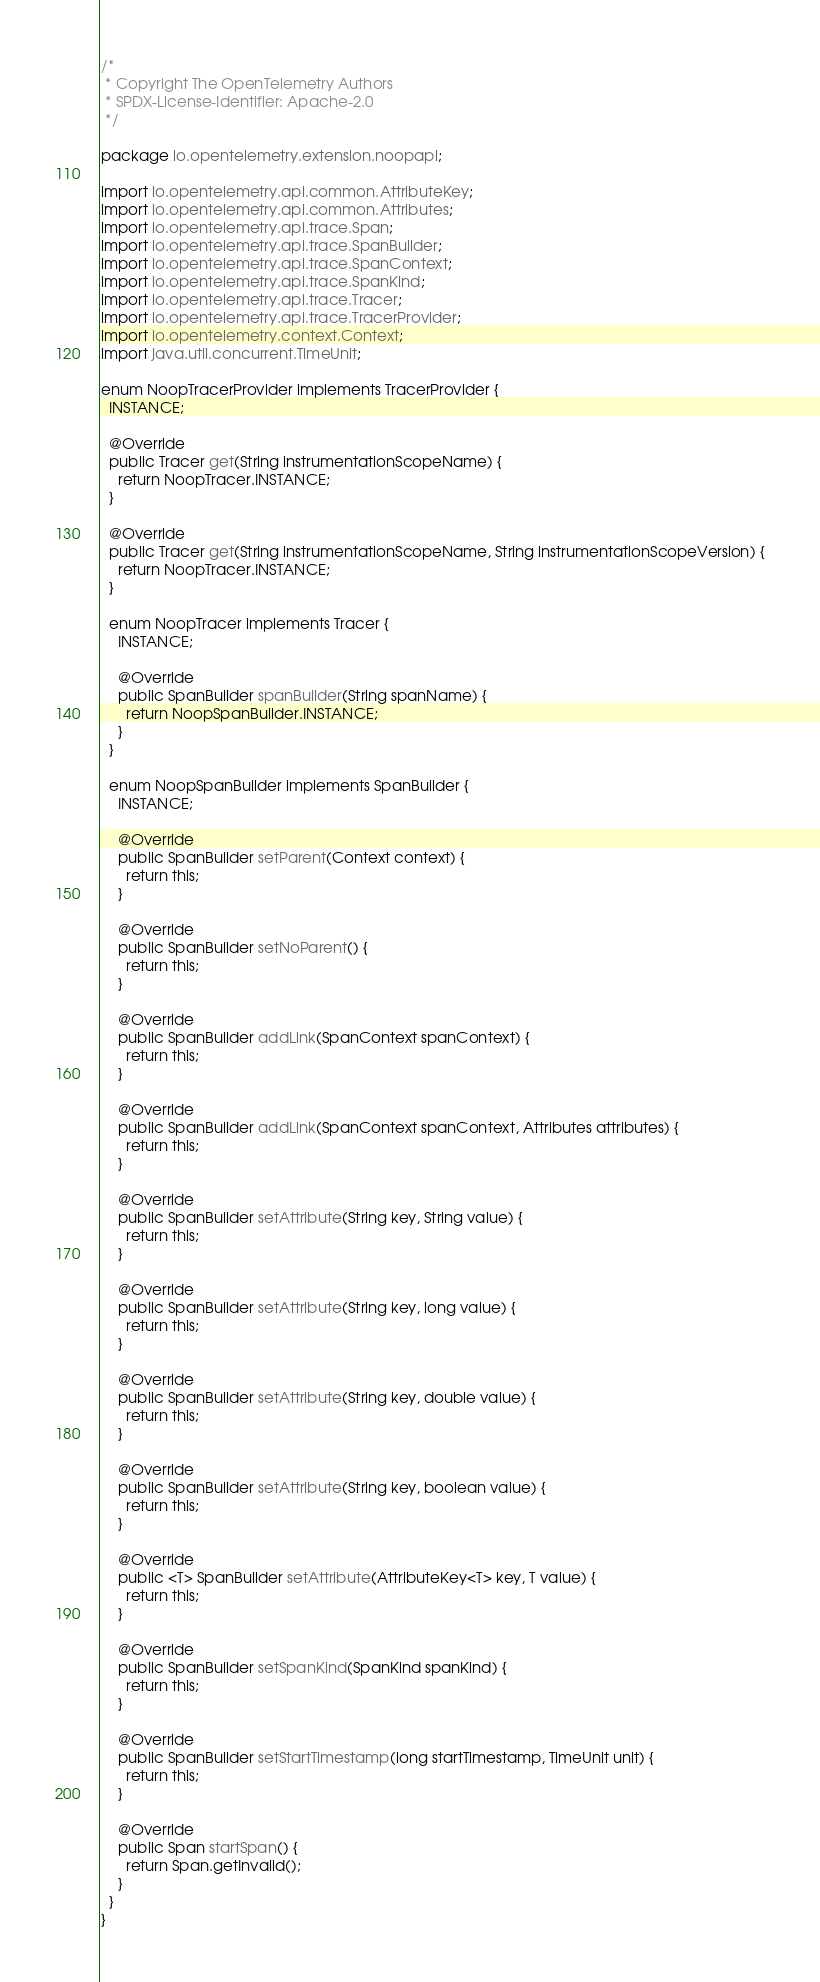Convert code to text. <code><loc_0><loc_0><loc_500><loc_500><_Java_>/*
 * Copyright The OpenTelemetry Authors
 * SPDX-License-Identifier: Apache-2.0
 */

package io.opentelemetry.extension.noopapi;

import io.opentelemetry.api.common.AttributeKey;
import io.opentelemetry.api.common.Attributes;
import io.opentelemetry.api.trace.Span;
import io.opentelemetry.api.trace.SpanBuilder;
import io.opentelemetry.api.trace.SpanContext;
import io.opentelemetry.api.trace.SpanKind;
import io.opentelemetry.api.trace.Tracer;
import io.opentelemetry.api.trace.TracerProvider;
import io.opentelemetry.context.Context;
import java.util.concurrent.TimeUnit;

enum NoopTracerProvider implements TracerProvider {
  INSTANCE;

  @Override
  public Tracer get(String instrumentationScopeName) {
    return NoopTracer.INSTANCE;
  }

  @Override
  public Tracer get(String instrumentationScopeName, String instrumentationScopeVersion) {
    return NoopTracer.INSTANCE;
  }

  enum NoopTracer implements Tracer {
    INSTANCE;

    @Override
    public SpanBuilder spanBuilder(String spanName) {
      return NoopSpanBuilder.INSTANCE;
    }
  }

  enum NoopSpanBuilder implements SpanBuilder {
    INSTANCE;

    @Override
    public SpanBuilder setParent(Context context) {
      return this;
    }

    @Override
    public SpanBuilder setNoParent() {
      return this;
    }

    @Override
    public SpanBuilder addLink(SpanContext spanContext) {
      return this;
    }

    @Override
    public SpanBuilder addLink(SpanContext spanContext, Attributes attributes) {
      return this;
    }

    @Override
    public SpanBuilder setAttribute(String key, String value) {
      return this;
    }

    @Override
    public SpanBuilder setAttribute(String key, long value) {
      return this;
    }

    @Override
    public SpanBuilder setAttribute(String key, double value) {
      return this;
    }

    @Override
    public SpanBuilder setAttribute(String key, boolean value) {
      return this;
    }

    @Override
    public <T> SpanBuilder setAttribute(AttributeKey<T> key, T value) {
      return this;
    }

    @Override
    public SpanBuilder setSpanKind(SpanKind spanKind) {
      return this;
    }

    @Override
    public SpanBuilder setStartTimestamp(long startTimestamp, TimeUnit unit) {
      return this;
    }

    @Override
    public Span startSpan() {
      return Span.getInvalid();
    }
  }
}
</code> 